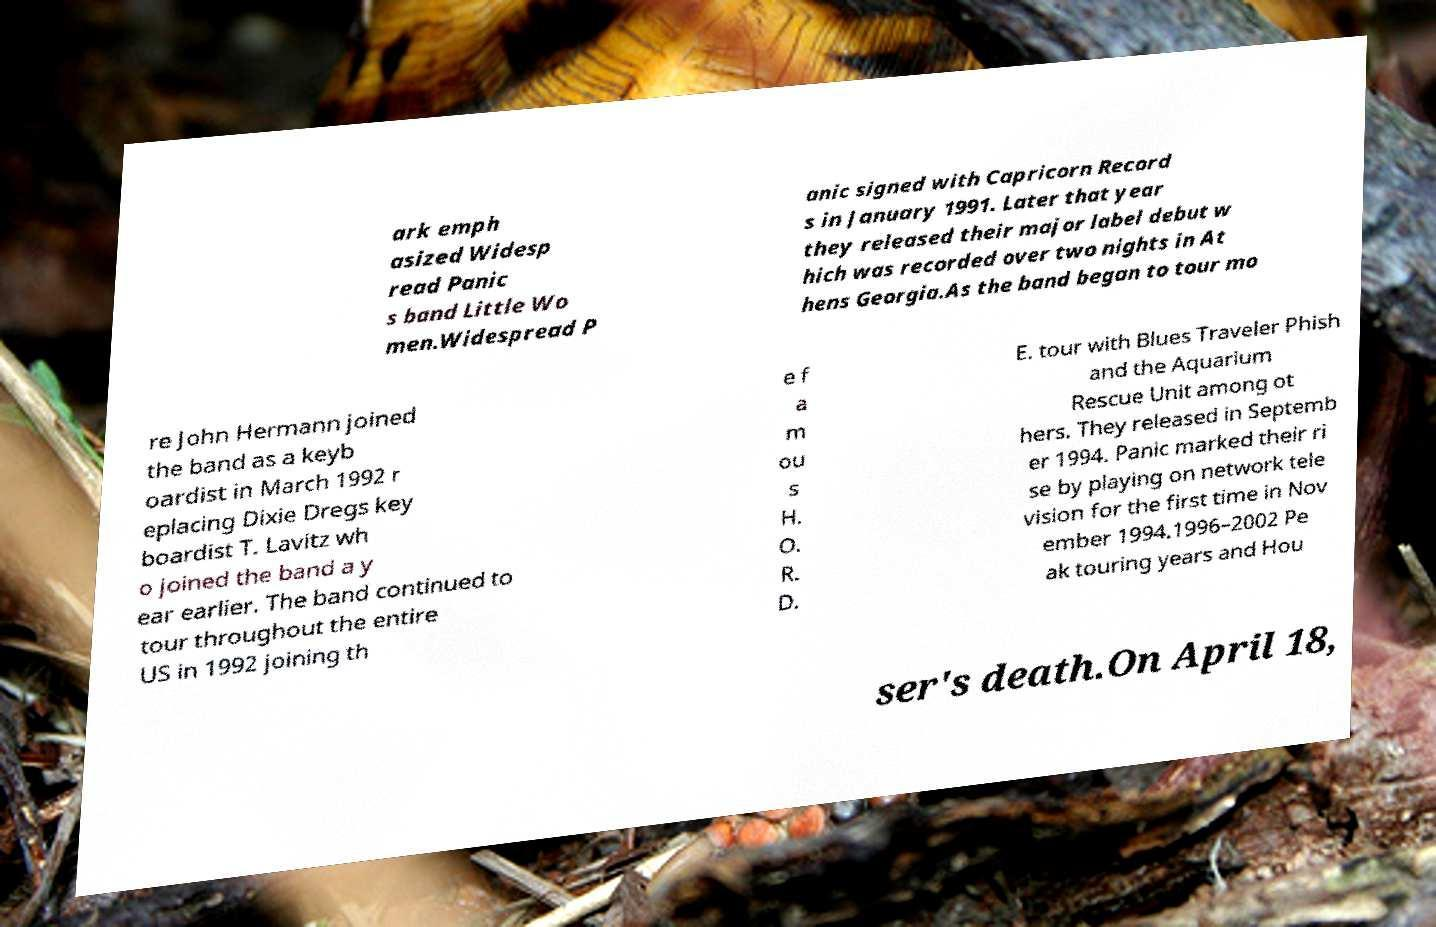Could you assist in decoding the text presented in this image and type it out clearly? ark emph asized Widesp read Panic s band Little Wo men.Widespread P anic signed with Capricorn Record s in January 1991. Later that year they released their major label debut w hich was recorded over two nights in At hens Georgia.As the band began to tour mo re John Hermann joined the band as a keyb oardist in March 1992 r eplacing Dixie Dregs key boardist T. Lavitz wh o joined the band a y ear earlier. The band continued to tour throughout the entire US in 1992 joining th e f a m ou s H. O. R. D. E. tour with Blues Traveler Phish and the Aquarium Rescue Unit among ot hers. They released in Septemb er 1994. Panic marked their ri se by playing on network tele vision for the first time in Nov ember 1994.1996–2002 Pe ak touring years and Hou ser's death.On April 18, 